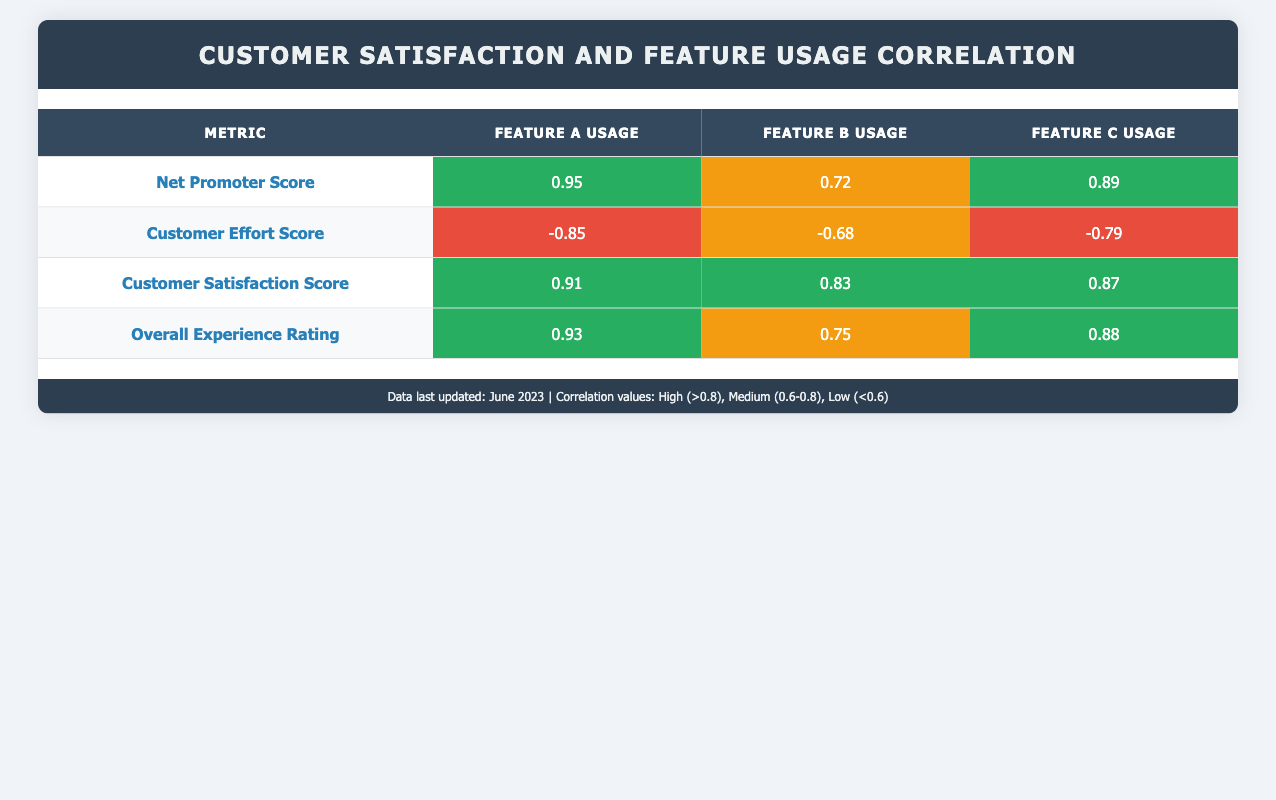What is the correlation between Net Promoter Score and Feature A Usage? The table shows that the correlation coefficient for Net Promoter Score and Feature A Usage is 0.95. This indicates a very strong positive correlation.
Answer: 0.95 What is the highest correlation among Customer Satisfaction Score and Feature Usage metrics? By comparing the values, the highest correlation for Customer Satisfaction Score is with Feature A Usage, which is 0.91.
Answer: 0.91 Is there a correlation between Customer Effort Score and Feature B Usage? The correlation coefficient for Customer Effort Score and Feature B Usage is -0.68. This indicates a medium negative correlation.
Answer: Yes What is the average correlation value for all metrics with Feature C Usage? The correlation values with Feature C Usage are 0.89, 0.79, 0.87, and 0.88. We first sum these values: (0.89 + 0.79 + 0.87 + 0.88) = 3.43. Since there are four metrics, the average is 3.43 / 4 = 0.8575.
Answer: 0.8575 Is the correlation between Overall Experience Rating and Feature C Usage high? The correlation coefficient between Overall Experience Rating and Feature C Usage is 0.88, which is classified as high (greater than 0.8).
Answer: Yes What is the difference in correlation values between Customer Satisfaction Score and Feature A Usage and Overall Experience Rating and Feature B Usage? The correlation for Customer Satisfaction Score with Feature A Usage is 0.91 and for Overall Experience Rating with Feature B Usage is 0.75. The difference is: 0.91 - 0.75 = 0.16.
Answer: 0.16 Which satisfaction metric has the lowest correlation with Feature A Usage? Looking at the correlations, Customer Effort Score has a correlation of -0.85 with Feature A Usage, which is the lowest among all metrics.
Answer: Customer Effort Score What is the overall relationship trend between feature usage and customer satisfaction metrics? The overall trend shows that as feature usage increases, customer satisfaction metrics such as Net Promoter Score and Customer Satisfaction Score tend to also increase. This can be inferred from the high positive correlation values presented in the table.
Answer: Positive trend 